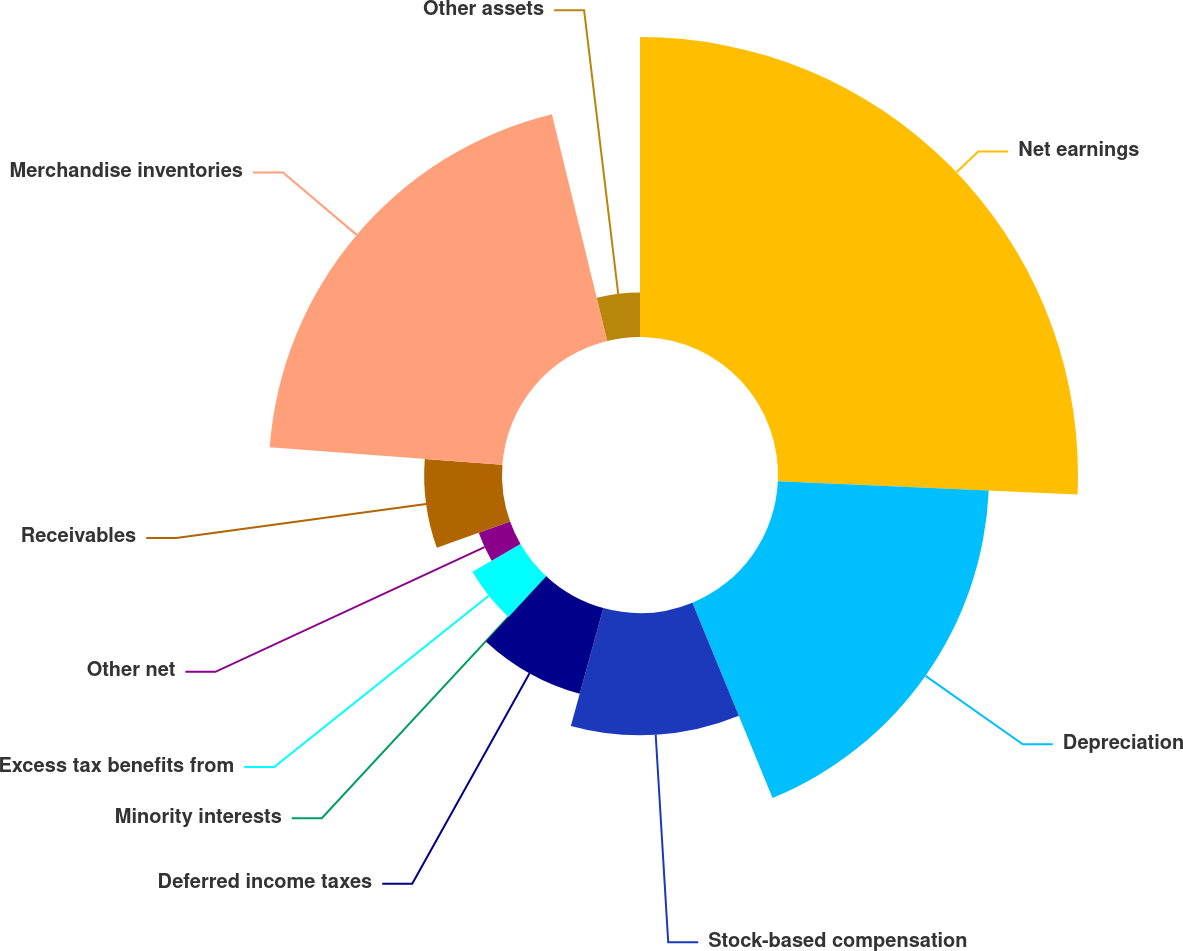Convert chart. <chart><loc_0><loc_0><loc_500><loc_500><pie_chart><fcel>Net earnings<fcel>Depreciation<fcel>Stock-based compensation<fcel>Deferred income taxes<fcel>Minority interests<fcel>Excess tax benefits from<fcel>Other net<fcel>Receivables<fcel>Merchandise inventories<fcel>Other assets<nl><fcel>25.71%<fcel>18.09%<fcel>10.48%<fcel>7.62%<fcel>0.0%<fcel>4.76%<fcel>2.86%<fcel>6.67%<fcel>20.0%<fcel>3.81%<nl></chart> 